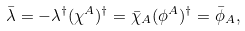Convert formula to latex. <formula><loc_0><loc_0><loc_500><loc_500>\bar { \lambda } = - \lambda ^ { \dagger } ( \chi ^ { A } ) ^ { \dagger } = \bar { \chi } _ { A } ( \phi ^ { A } ) ^ { \dagger } = \bar { \phi } _ { A } ,</formula> 